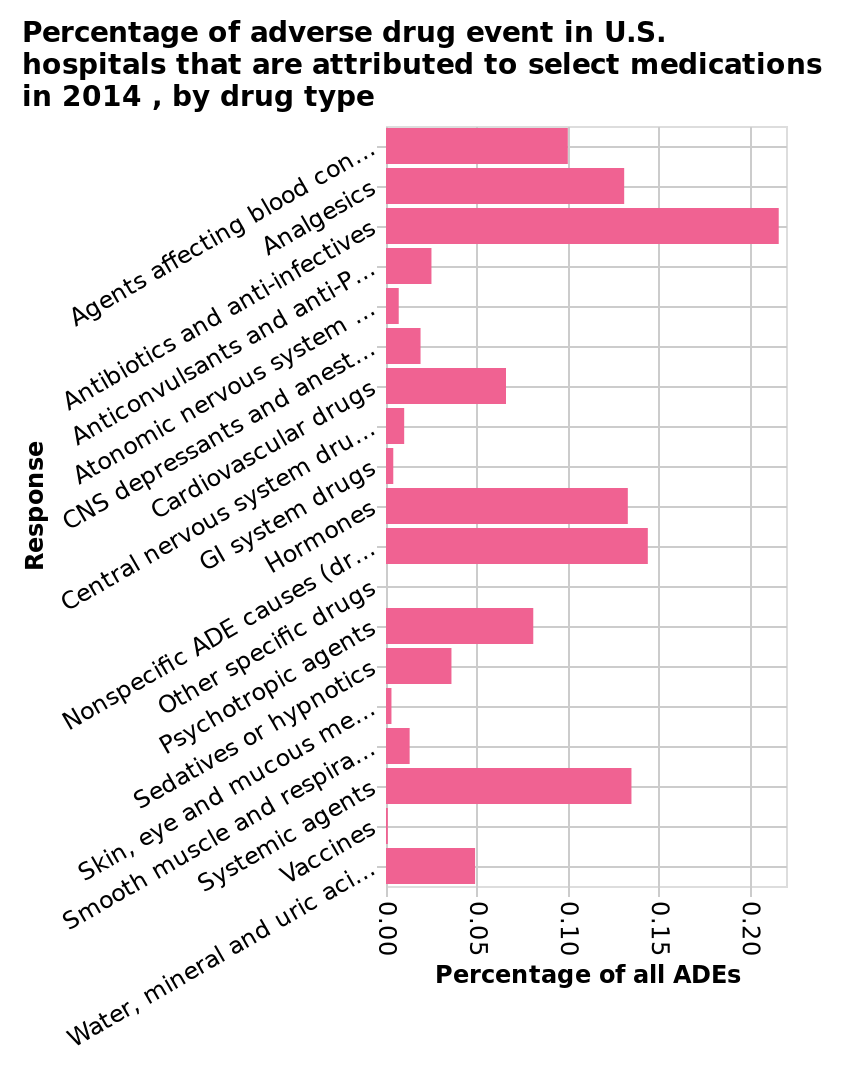<image>
In what year did the comparison of alternative and traditional finance providers take place? 2014. What is represented on the y-axis of the bar diagram? The y-axis represents the response variable. Which category had the lowest percentage of Adverse Drug Events (ADE's) in US hospitals in 2014?  Vaccines. Offer a thorough analysis of the image. Anti-biotics and Anti-infectives saw the highest percentage of ADE's in US hospitals in 2014. Vaccines were the lowest percentage of ADE's in US hospitals in 2014. What is the scale on the x-axis of the bar diagram? The x-axis has a linear scale ranging from 0.00 to 0.20. 